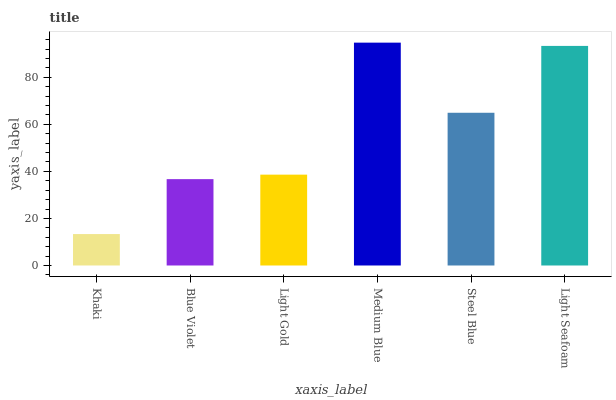Is Khaki the minimum?
Answer yes or no. Yes. Is Medium Blue the maximum?
Answer yes or no. Yes. Is Blue Violet the minimum?
Answer yes or no. No. Is Blue Violet the maximum?
Answer yes or no. No. Is Blue Violet greater than Khaki?
Answer yes or no. Yes. Is Khaki less than Blue Violet?
Answer yes or no. Yes. Is Khaki greater than Blue Violet?
Answer yes or no. No. Is Blue Violet less than Khaki?
Answer yes or no. No. Is Steel Blue the high median?
Answer yes or no. Yes. Is Light Gold the low median?
Answer yes or no. Yes. Is Light Seafoam the high median?
Answer yes or no. No. Is Steel Blue the low median?
Answer yes or no. No. 